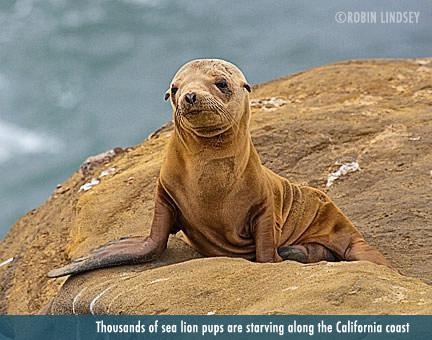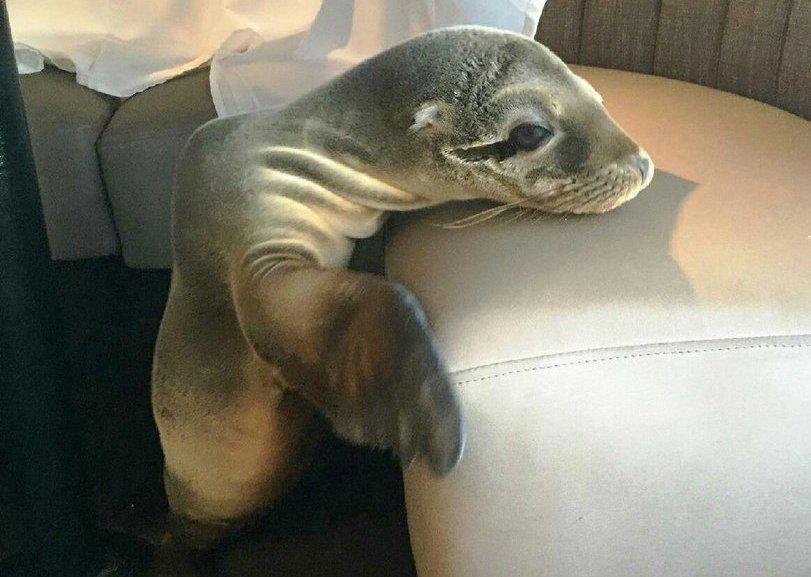The first image is the image on the left, the second image is the image on the right. Assess this claim about the two images: "An image shows an adult seal on the right with its neck turned to point its nose down toward a baby seal.". Correct or not? Answer yes or no. No. The first image is the image on the left, the second image is the image on the right. Assess this claim about the two images: "The right image contains an adult seal with a child seal.". Correct or not? Answer yes or no. No. 